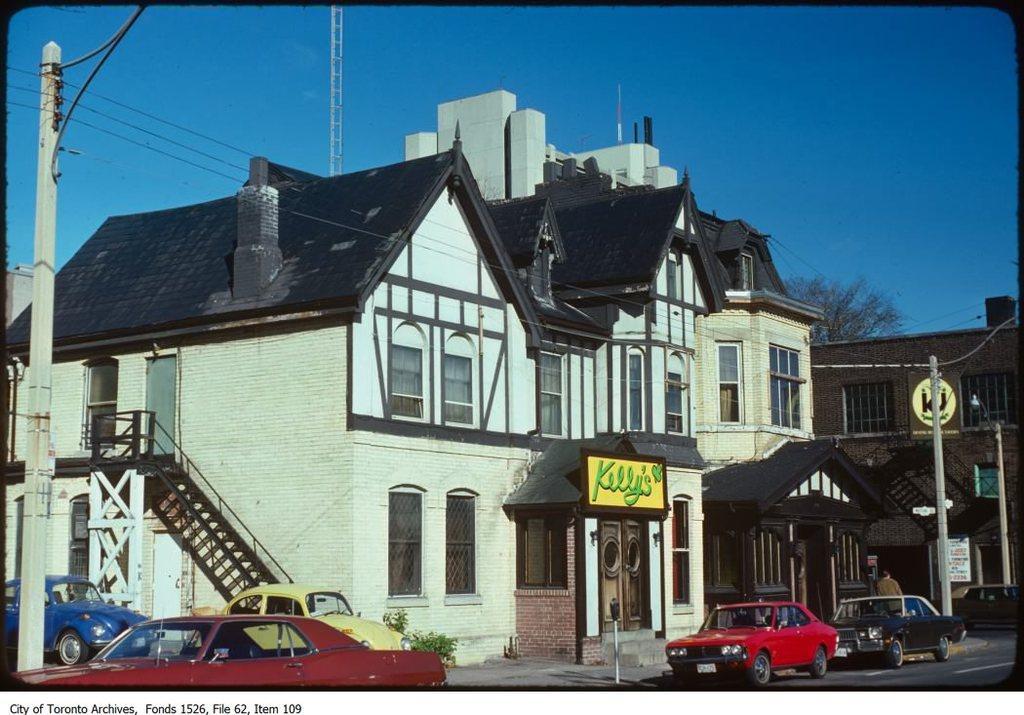How would you summarize this image in a sentence or two? This image consists of buildings along with windows and doors. At the bottom, there are cars parked on the road. On the left, we can see a pole along with wires. At the top, there is sky. On the right, we can see a tree. 